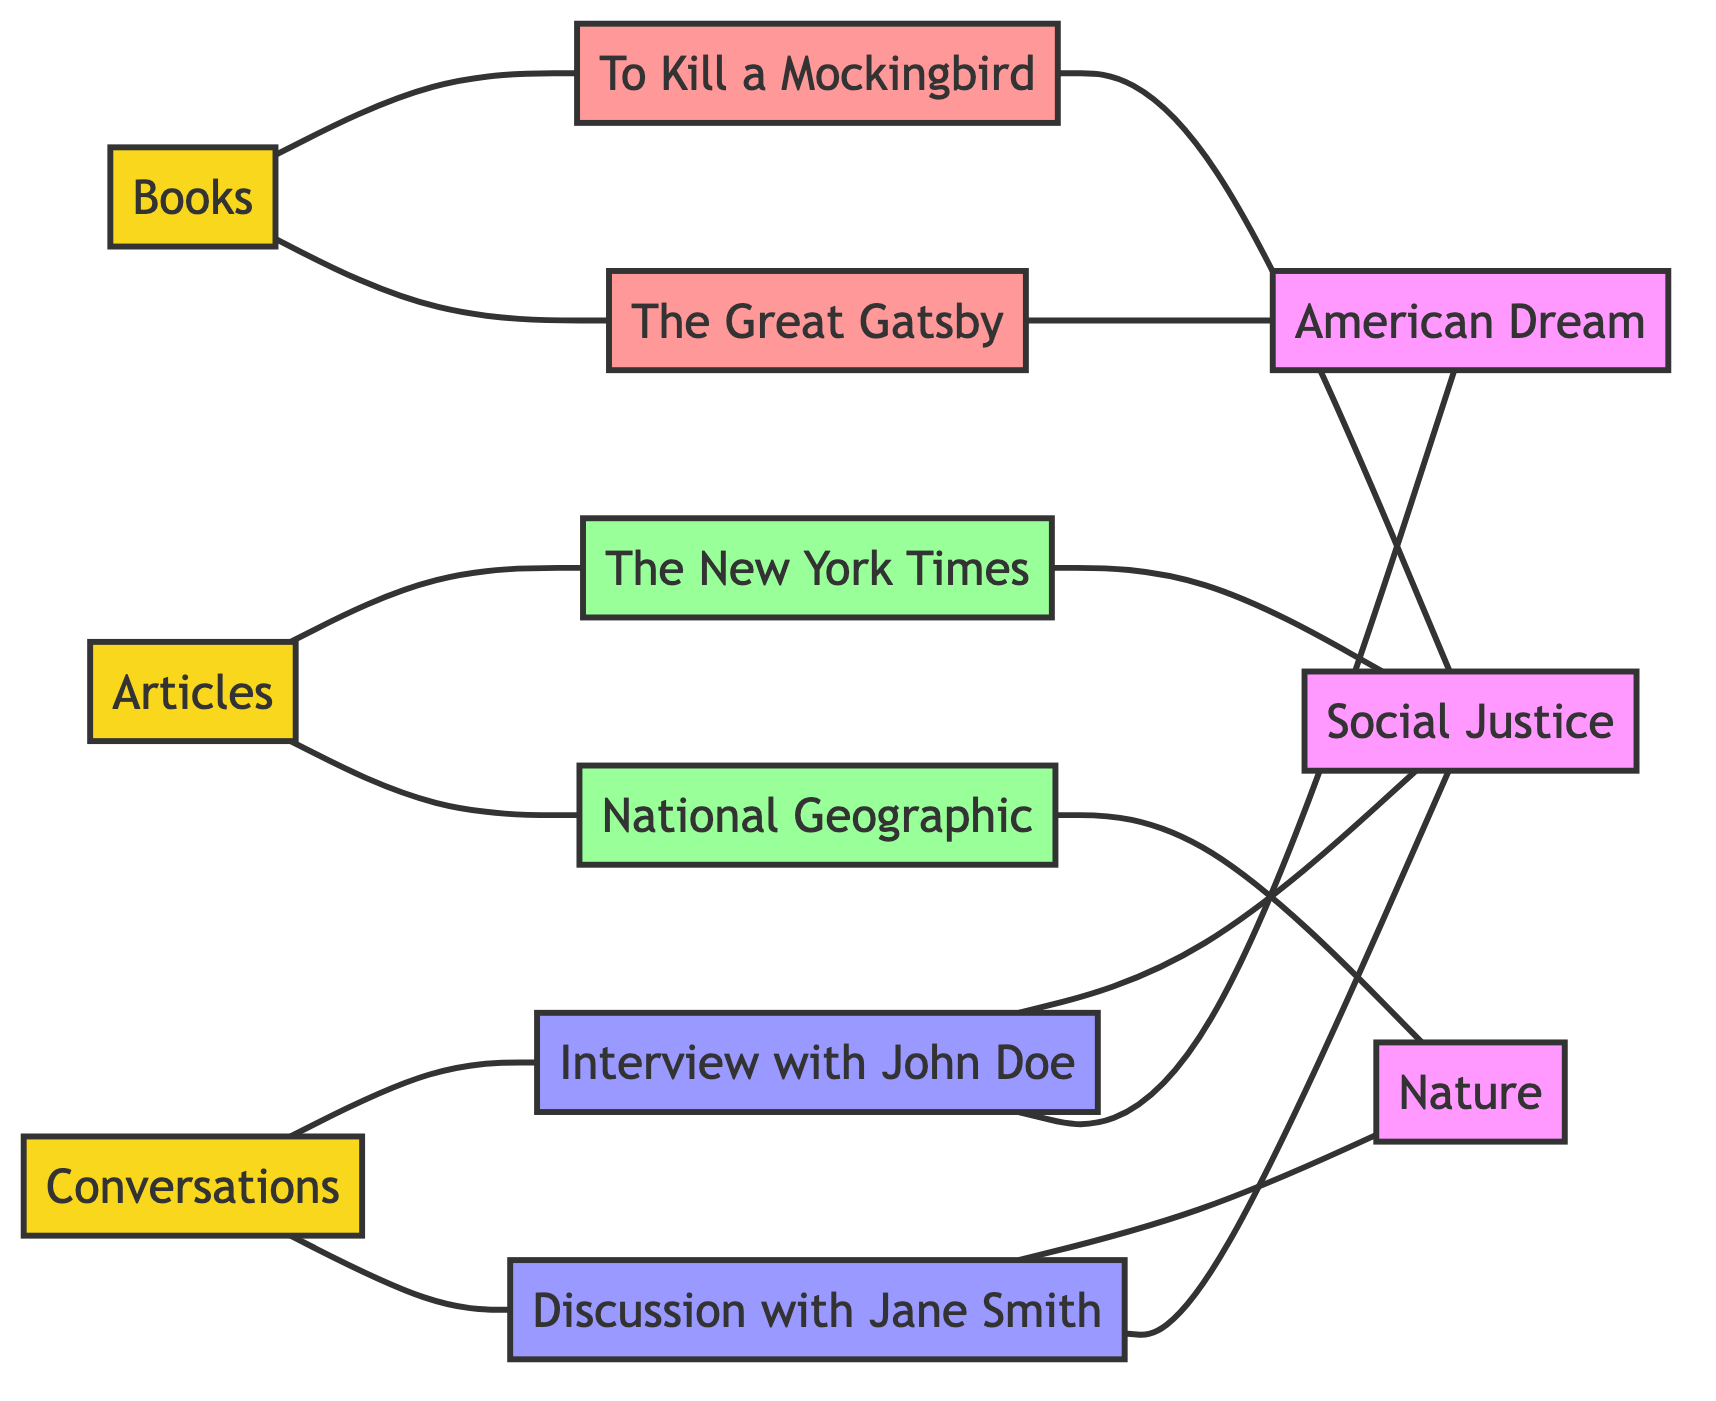What are the three main types of inspiration sources in this diagram? The diagram lists three sources of inspiration categorized as nodes: Books, Articles, and Conversations.
Answer: Books, Articles, Conversations How many total nodes are present in the diagram? Counting all listed sources, books, articles, conversations, and themes, there are 12 nodes in total.
Answer: 12 Which book explores the theme of Social Justice? The edge connecting "To Kill a Mockingbird" to the theme of Social Justice indicates that this book explores that theme.
Answer: To Kill a Mockingbird What type of article covers the theme of Nature? The diagram shows that the "National Geographic" article is connected to the theme of Nature, indicating it covers that theme.
Answer: National Geographic How many edges connect the source "Conversations" to other nodes? The "Conversations" source connects to two nodes: Interview with John Doe and Discussion with Jane Smith, which includes additional connections to themes. Counting these connections gives a total of four edges.
Answer: 4 Which two themes are discussed in the "Discussion with Jane Smith"? From the edges, "Discussion with Jane Smith" mentions and discusses Social Justice and Nature, indicating a connection to both themes.
Answer: Social Justice, Nature Which book is connected to the theme of the American Dream? The edge leading from "The Great Gatsby" indicates this book explores the theme of the American Dream.
Answer: The Great Gatsby How many edges are associated with the node "Articles"? The "Articles" source contains connections to two articles: The New York Times and National Geographic, which results in two edges directly stemming from it.
Answer: 2 Which conversation mentions the theme of Social Justice? The edge shows that the "Interview with John Doe" mentions Social Justice, indicating a connection between this conversation and the theme.
Answer: Interview with John Doe 